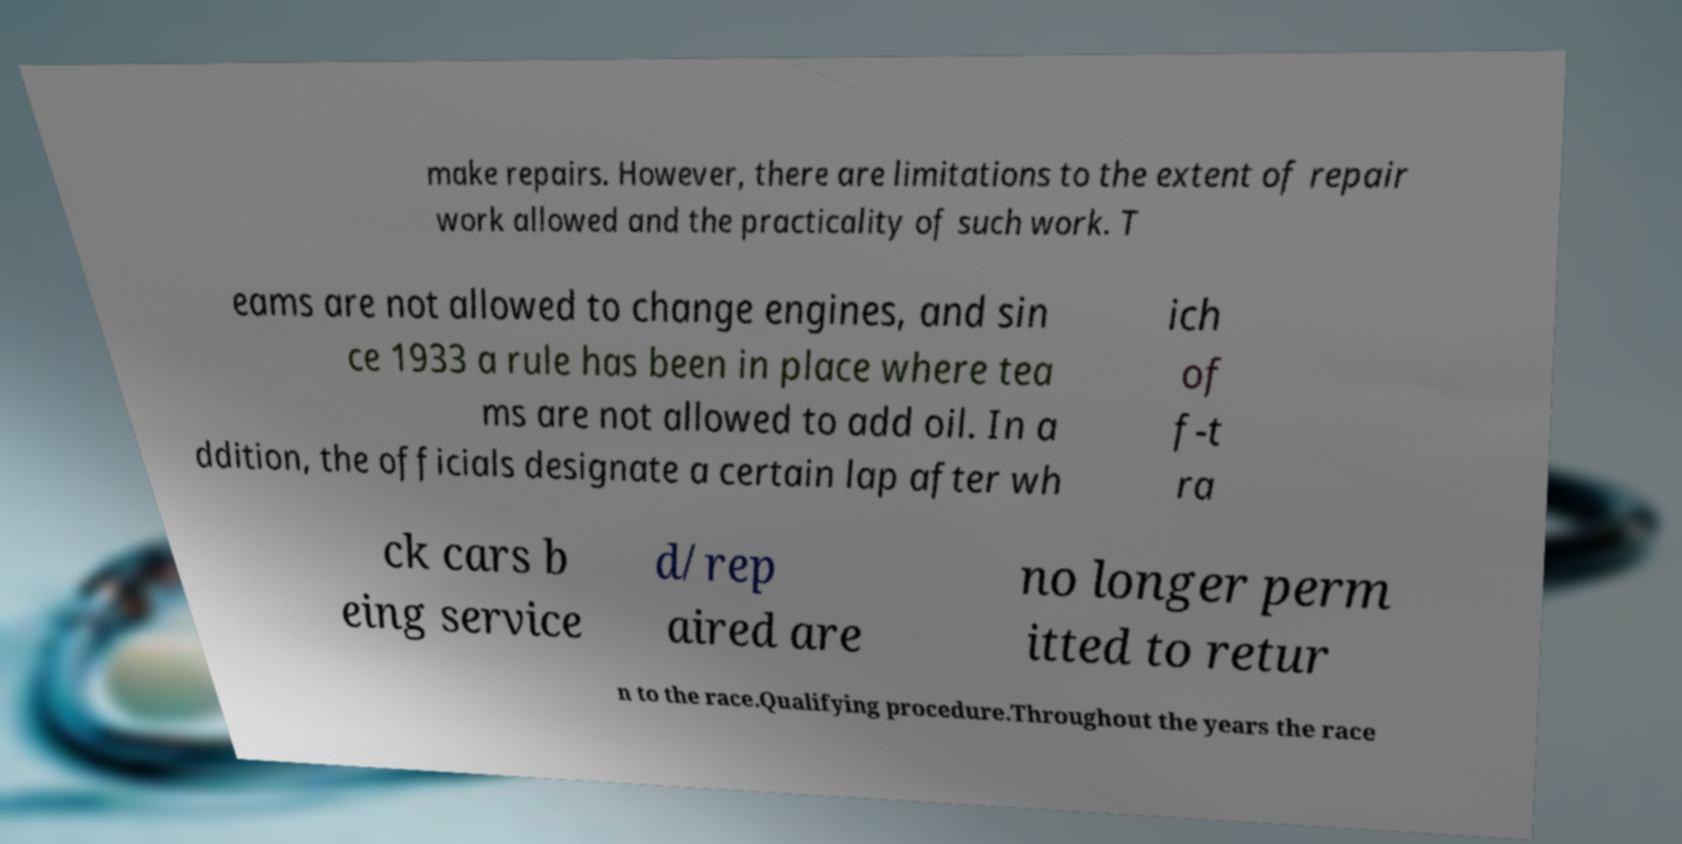What messages or text are displayed in this image? I need them in a readable, typed format. make repairs. However, there are limitations to the extent of repair work allowed and the practicality of such work. T eams are not allowed to change engines, and sin ce 1933 a rule has been in place where tea ms are not allowed to add oil. In a ddition, the officials designate a certain lap after wh ich of f-t ra ck cars b eing service d/rep aired are no longer perm itted to retur n to the race.Qualifying procedure.Throughout the years the race 